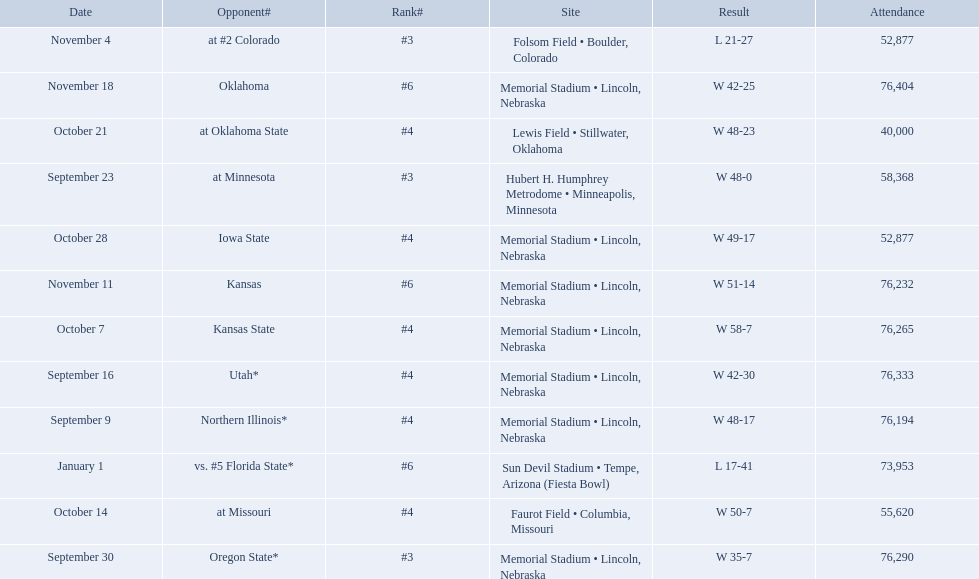Who were all of their opponents? Northern Illinois*, Utah*, at Minnesota, Oregon State*, Kansas State, at Missouri, at Oklahoma State, Iowa State, at #2 Colorado, Kansas, Oklahoma, vs. #5 Florida State*. And what was the attendance of these games? 76,194, 76,333, 58,368, 76,290, 76,265, 55,620, 40,000, 52,877, 52,877, 76,232, 76,404, 73,953. Of those numbers, which is associated with the oregon state game? 76,290. 